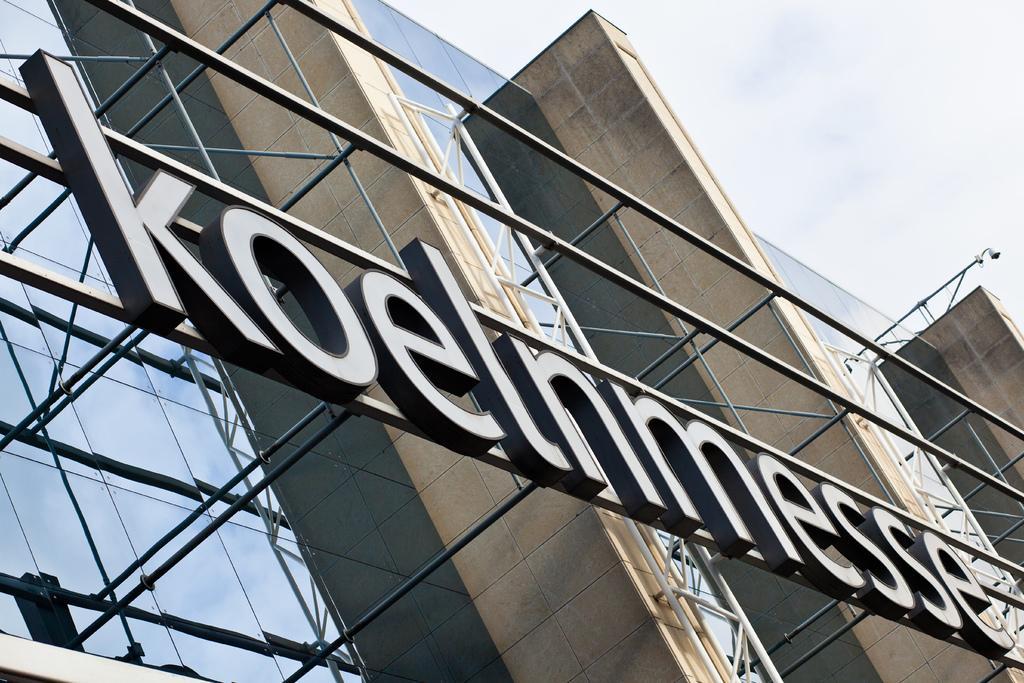Can you describe this image briefly? As we can see in the image there are buildings, light and on the top there is sky. 